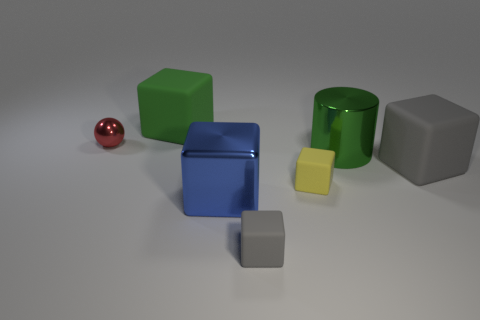How many cyan objects are either big matte blocks or metallic blocks?
Ensure brevity in your answer.  0. There is a big object that is behind the big cylinder; does it have the same shape as the gray rubber thing that is behind the small gray rubber block?
Ensure brevity in your answer.  Yes. There is a small sphere; is its color the same as the shiny object that is on the right side of the yellow rubber cube?
Provide a succinct answer. No. Is the color of the large matte cube that is to the left of the blue thing the same as the big shiny block?
Provide a short and direct response. No. What number of things are either big green cubes or small objects behind the big green cylinder?
Provide a succinct answer. 2. What material is the object that is both behind the green shiny cylinder and to the right of the tiny red ball?
Make the answer very short. Rubber. What is the material of the large green object that is behind the tiny metal ball?
Keep it short and to the point. Rubber. There is a large cube that is made of the same material as the ball; what is its color?
Offer a terse response. Blue. There is a tiny red shiny thing; is its shape the same as the gray thing behind the small gray matte cube?
Make the answer very short. No. Are there any big gray blocks in front of the yellow cube?
Ensure brevity in your answer.  No. 